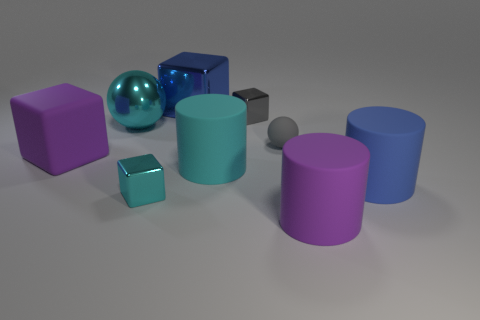How many things are cyan blocks or tiny gray shiny blocks? In the image, there is a total of 1 cyan block, which is a cube, and there is also 1 tiny gray shiny sphere. So, there are 2 objects that match the criteria of being either cyan blocks or tiny gray shiny blocks. 